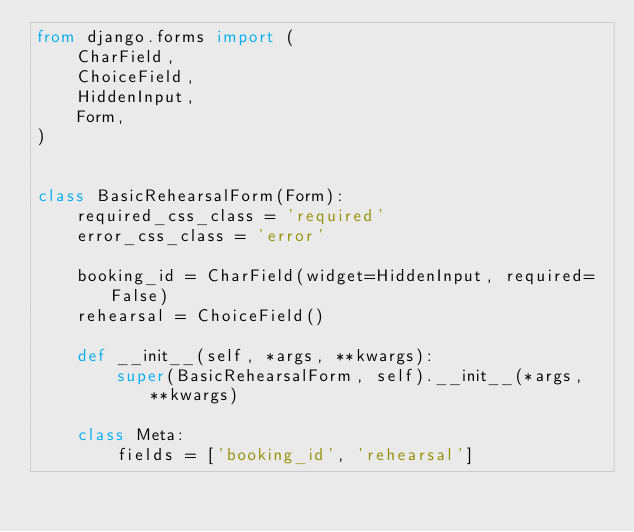<code> <loc_0><loc_0><loc_500><loc_500><_Python_>from django.forms import (
    CharField,
    ChoiceField,
    HiddenInput,
    Form,
)


class BasicRehearsalForm(Form):
    required_css_class = 'required'
    error_css_class = 'error'

    booking_id = CharField(widget=HiddenInput, required=False)
    rehearsal = ChoiceField()

    def __init__(self, *args, **kwargs):
        super(BasicRehearsalForm, self).__init__(*args, **kwargs)

    class Meta:
        fields = ['booking_id', 'rehearsal']
</code> 